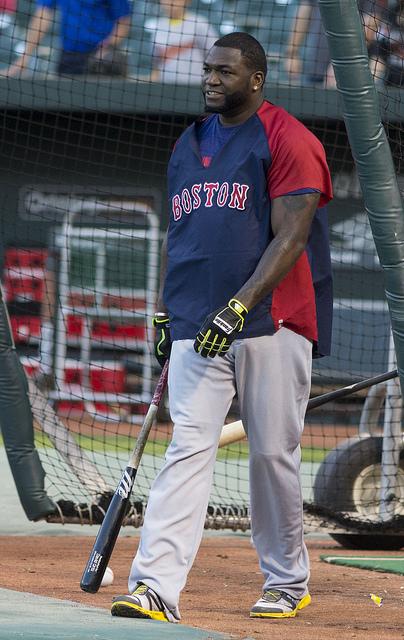Is the man wearing gloves?
Answer briefly. Yes. Does he play baseball for a high school team?
Concise answer only. No. What team is he playing for?
Answer briefly. Boston. Is the player skinny or fat?
Write a very short answer. Fat. What team does this baseball player play for?
Be succinct. Boston. What team does the man play for?
Answer briefly. Boston. Which is his Jersey written?
Write a very short answer. Boston. What team is the batter on?
Answer briefly. Boston. Where on the ball field is this man?
Quick response, please. Dugout. 